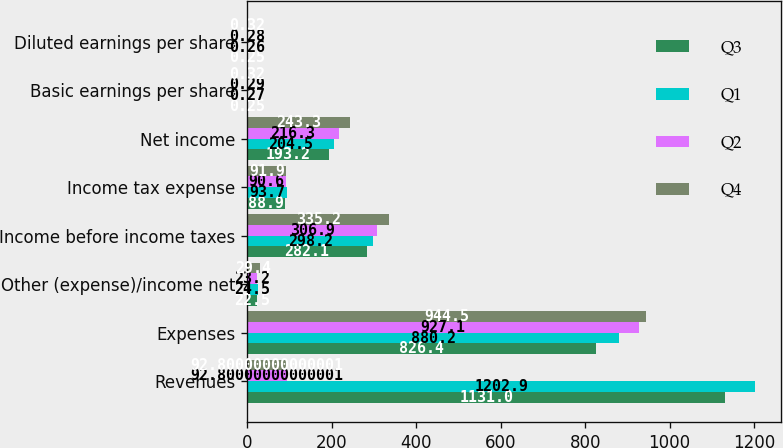Convert chart. <chart><loc_0><loc_0><loc_500><loc_500><stacked_bar_chart><ecel><fcel>Revenues<fcel>Expenses<fcel>Other (expense)/income net<fcel>Income before income taxes<fcel>Income tax expense<fcel>Net income<fcel>Basic earnings per share<fcel>Diluted earnings per share<nl><fcel>Q3<fcel>1131<fcel>826.4<fcel>22.5<fcel>282.1<fcel>88.9<fcel>193.2<fcel>0.25<fcel>0.25<nl><fcel>Q1<fcel>1202.9<fcel>880.2<fcel>24.5<fcel>298.2<fcel>93.7<fcel>204.5<fcel>0.27<fcel>0.26<nl><fcel>Q2<fcel>92.8<fcel>927.1<fcel>23.2<fcel>306.9<fcel>90.6<fcel>216.3<fcel>0.29<fcel>0.28<nl><fcel>Q4<fcel>92.8<fcel>944.5<fcel>29.4<fcel>335.2<fcel>91.9<fcel>243.3<fcel>0.32<fcel>0.32<nl></chart> 